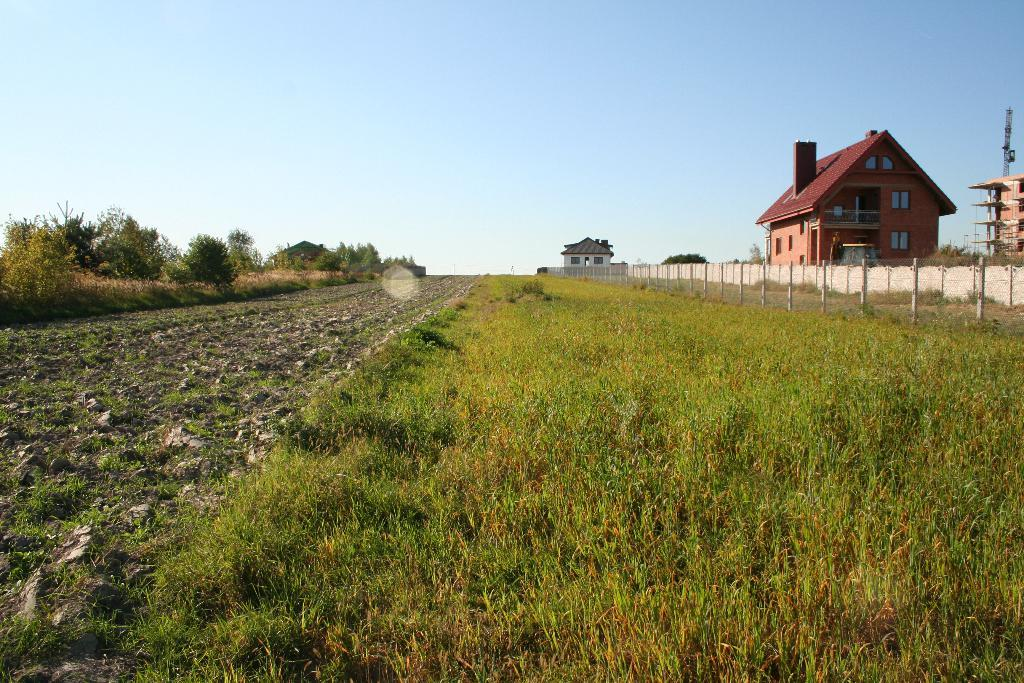What type of vegetation is at the bottom of the image? There is grass at the bottom of the image. What is located on the right side of the image? There is a fence and buildings on the right side of the image. What type of vegetation is on the left side of the image? There are trees on the left side of the image. What is visible at the top of the image? The sky is visible at the top of the image. What type of coil can be seen in the image? There is no coil present in the image. How does the judge interact with the trees in the image? There is no judge present in the image, so there is no interaction with the trees. 